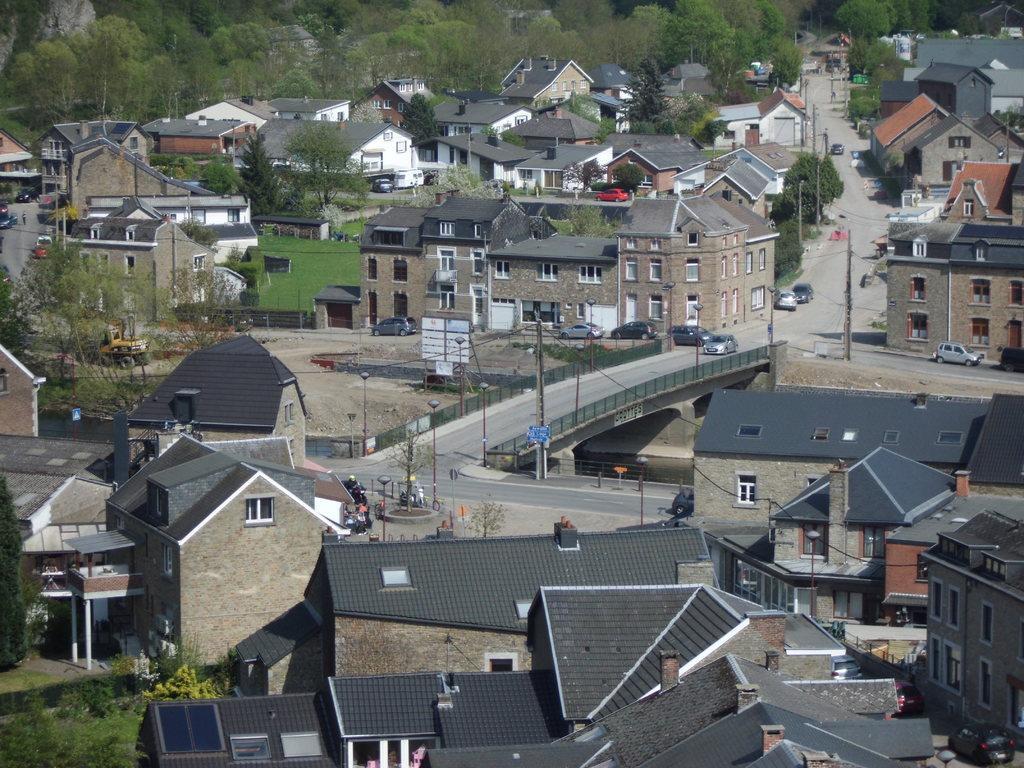In one or two sentences, can you explain what this image depicts? In this image there are buildings and there are cars on the road, there are poles and there are trees and there is grass on the ground on the bottom left. 